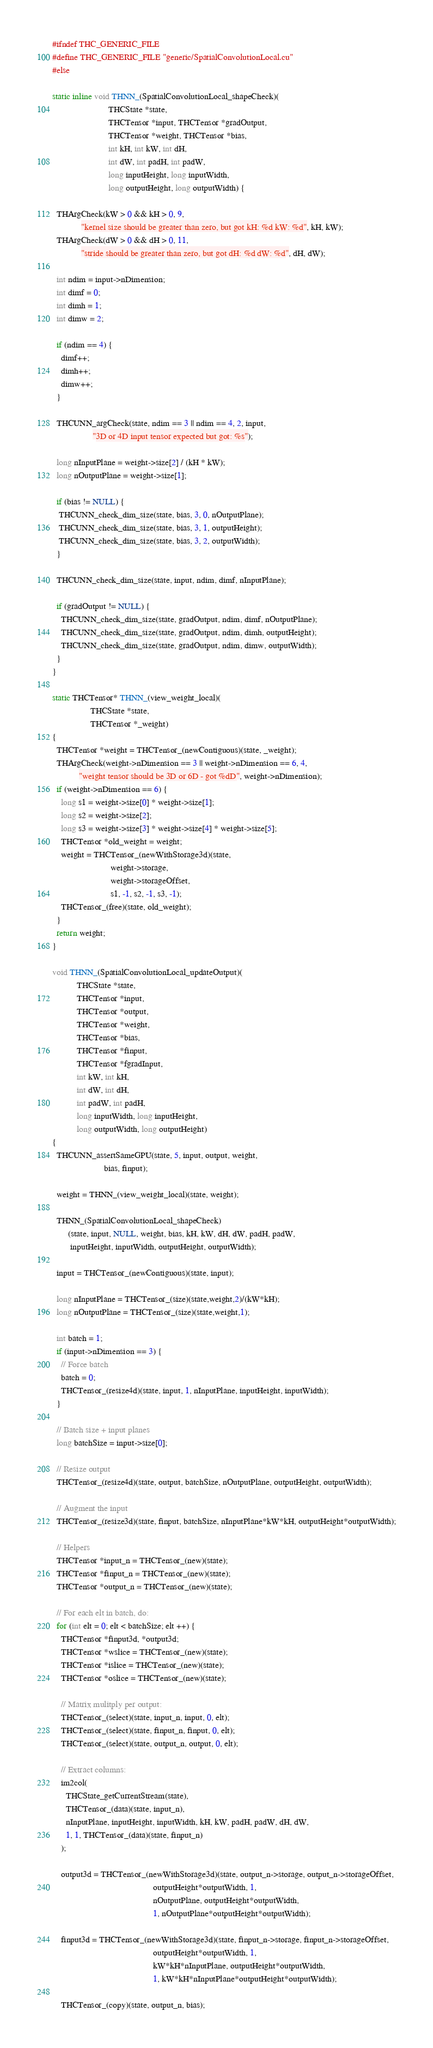Convert code to text. <code><loc_0><loc_0><loc_500><loc_500><_Cuda_>#ifndef THC_GENERIC_FILE
#define THC_GENERIC_FILE "generic/SpatialConvolutionLocal.cu"
#else

static inline void THNN_(SpatialConvolutionLocal_shapeCheck)(
                         THCState *state,
                         THCTensor *input, THCTensor *gradOutput,
                         THCTensor *weight, THCTensor *bias,
                         int kH, int kW, int dH,
                         int dW, int padH, int padW,
                         long inputHeight, long inputWidth,
                         long outputHeight, long outputWidth) {

  THArgCheck(kW > 0 && kH > 0, 9,
             "kernel size should be greater than zero, but got kH: %d kW: %d", kH, kW);
  THArgCheck(dW > 0 && dH > 0, 11,
             "stride should be greater than zero, but got dH: %d dW: %d", dH, dW);

  int ndim = input->nDimension;
  int dimf = 0;
  int dimh = 1;
  int dimw = 2;

  if (ndim == 4) {
    dimf++;
    dimh++;
    dimw++;
  }

  THCUNN_argCheck(state, ndim == 3 || ndim == 4, 2, input,
                  "3D or 4D input tensor expected but got: %s");

  long nInputPlane = weight->size[2] / (kH * kW);
  long nOutputPlane = weight->size[1];

  if (bias != NULL) {
   THCUNN_check_dim_size(state, bias, 3, 0, nOutputPlane);
   THCUNN_check_dim_size(state, bias, 3, 1, outputHeight);
   THCUNN_check_dim_size(state, bias, 3, 2, outputWidth);
  }

  THCUNN_check_dim_size(state, input, ndim, dimf, nInputPlane);

  if (gradOutput != NULL) {
    THCUNN_check_dim_size(state, gradOutput, ndim, dimf, nOutputPlane);
    THCUNN_check_dim_size(state, gradOutput, ndim, dimh, outputHeight);
    THCUNN_check_dim_size(state, gradOutput, ndim, dimw, outputWidth);
  }
}

static THCTensor* THNN_(view_weight_local)(
                 THCState *state,
                 THCTensor *_weight)
{
  THCTensor *weight = THCTensor_(newContiguous)(state, _weight);
  THArgCheck(weight->nDimension == 3 || weight->nDimension == 6, 4,
            "weight tensor should be 3D or 6D - got %dD", weight->nDimension);
  if (weight->nDimension == 6) {
    long s1 = weight->size[0] * weight->size[1];
    long s2 = weight->size[2];
    long s3 = weight->size[3] * weight->size[4] * weight->size[5];
    THCTensor *old_weight = weight;
    weight = THCTensor_(newWithStorage3d)(state,
                          weight->storage,
                          weight->storageOffset,
                          s1, -1, s2, -1, s3, -1);
    THCTensor_(free)(state, old_weight);
  }
  return weight;
}

void THNN_(SpatialConvolutionLocal_updateOutput)(
           THCState *state,
           THCTensor *input,
           THCTensor *output,
           THCTensor *weight,
           THCTensor *bias,
           THCTensor *finput,
           THCTensor *fgradInput,
           int kW, int kH,
           int dW, int dH,
           int padW, int padH,
           long inputWidth, long inputHeight,
           long outputWidth, long outputHeight)
{
  THCUNN_assertSameGPU(state, 5, input, output, weight,
                       bias, finput);

  weight = THNN_(view_weight_local)(state, weight);

  THNN_(SpatialConvolutionLocal_shapeCheck)
       (state, input, NULL, weight, bias, kH, kW, dH, dW, padH, padW,
        inputHeight, inputWidth, outputHeight, outputWidth);

  input = THCTensor_(newContiguous)(state, input);

  long nInputPlane = THCTensor_(size)(state,weight,2)/(kW*kH);
  long nOutputPlane = THCTensor_(size)(state,weight,1);

  int batch = 1;
  if (input->nDimension == 3) {
    // Force batch
    batch = 0;
    THCTensor_(resize4d)(state, input, 1, nInputPlane, inputHeight, inputWidth);
  }

  // Batch size + input planes
  long batchSize = input->size[0];

  // Resize output
  THCTensor_(resize4d)(state, output, batchSize, nOutputPlane, outputHeight, outputWidth);

  // Augment the input
  THCTensor_(resize3d)(state, finput, batchSize, nInputPlane*kW*kH, outputHeight*outputWidth);

  // Helpers
  THCTensor *input_n = THCTensor_(new)(state);
  THCTensor *finput_n = THCTensor_(new)(state);
  THCTensor *output_n = THCTensor_(new)(state);

  // For each elt in batch, do:
  for (int elt = 0; elt < batchSize; elt ++) {
    THCTensor *finput3d, *output3d;
    THCTensor *wslice = THCTensor_(new)(state);
    THCTensor *islice = THCTensor_(new)(state);
    THCTensor *oslice = THCTensor_(new)(state);

    // Matrix mulitply per output:
    THCTensor_(select)(state, input_n, input, 0, elt);
    THCTensor_(select)(state, finput_n, finput, 0, elt);
    THCTensor_(select)(state, output_n, output, 0, elt);

    // Extract columns:
    im2col(
      THCState_getCurrentStream(state),
      THCTensor_(data)(state, input_n),
      nInputPlane, inputHeight, inputWidth, kH, kW, padH, padW, dH, dW,
      1, 1, THCTensor_(data)(state, finput_n)
    );

    output3d = THCTensor_(newWithStorage3d)(state, output_n->storage, output_n->storageOffset,
                                             outputHeight*outputWidth, 1,
                                             nOutputPlane, outputHeight*outputWidth,
                                             1, nOutputPlane*outputHeight*outputWidth);

    finput3d = THCTensor_(newWithStorage3d)(state, finput_n->storage, finput_n->storageOffset,
                                             outputHeight*outputWidth, 1,
                                             kW*kH*nInputPlane, outputHeight*outputWidth,
                                             1, kW*kH*nInputPlane*outputHeight*outputWidth);

    THCTensor_(copy)(state, output_n, bias);
</code> 